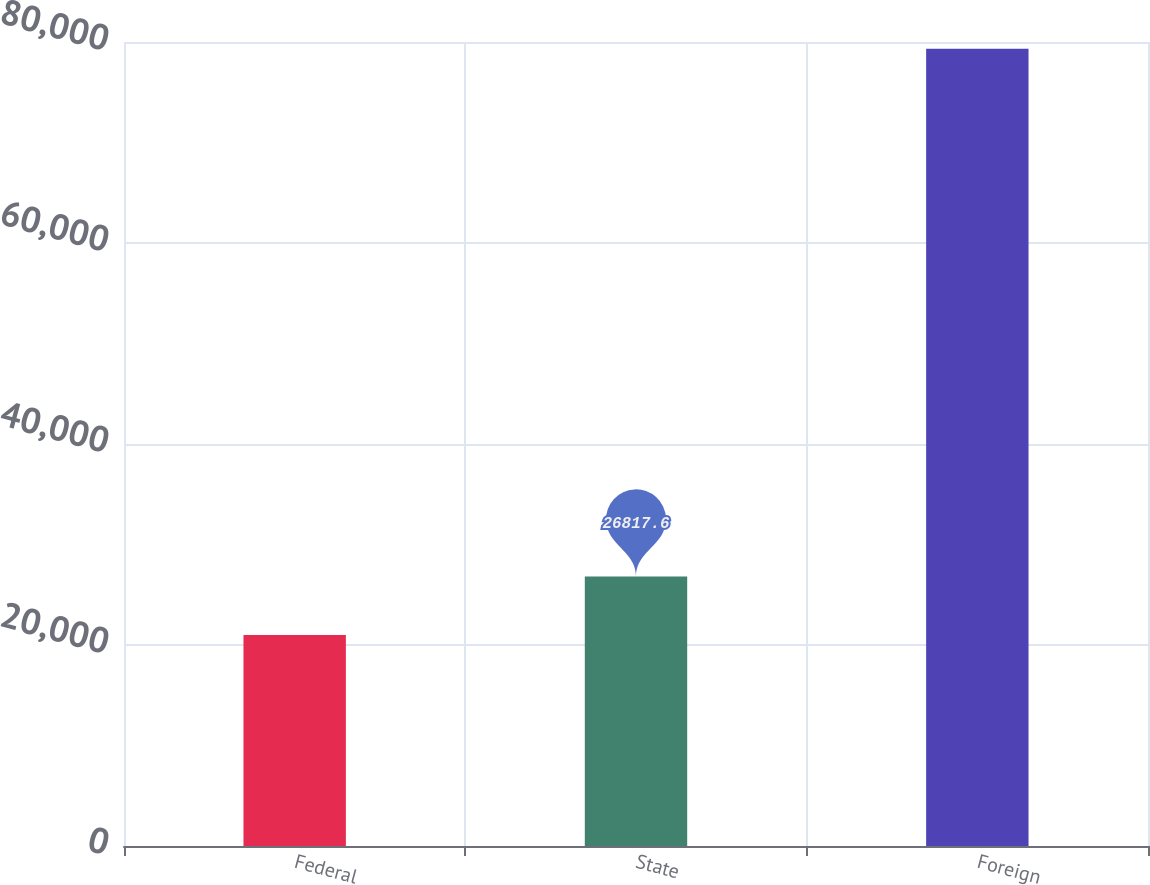Convert chart. <chart><loc_0><loc_0><loc_500><loc_500><bar_chart><fcel>Federal<fcel>State<fcel>Foreign<nl><fcel>20984<fcel>26817.6<fcel>79320<nl></chart> 